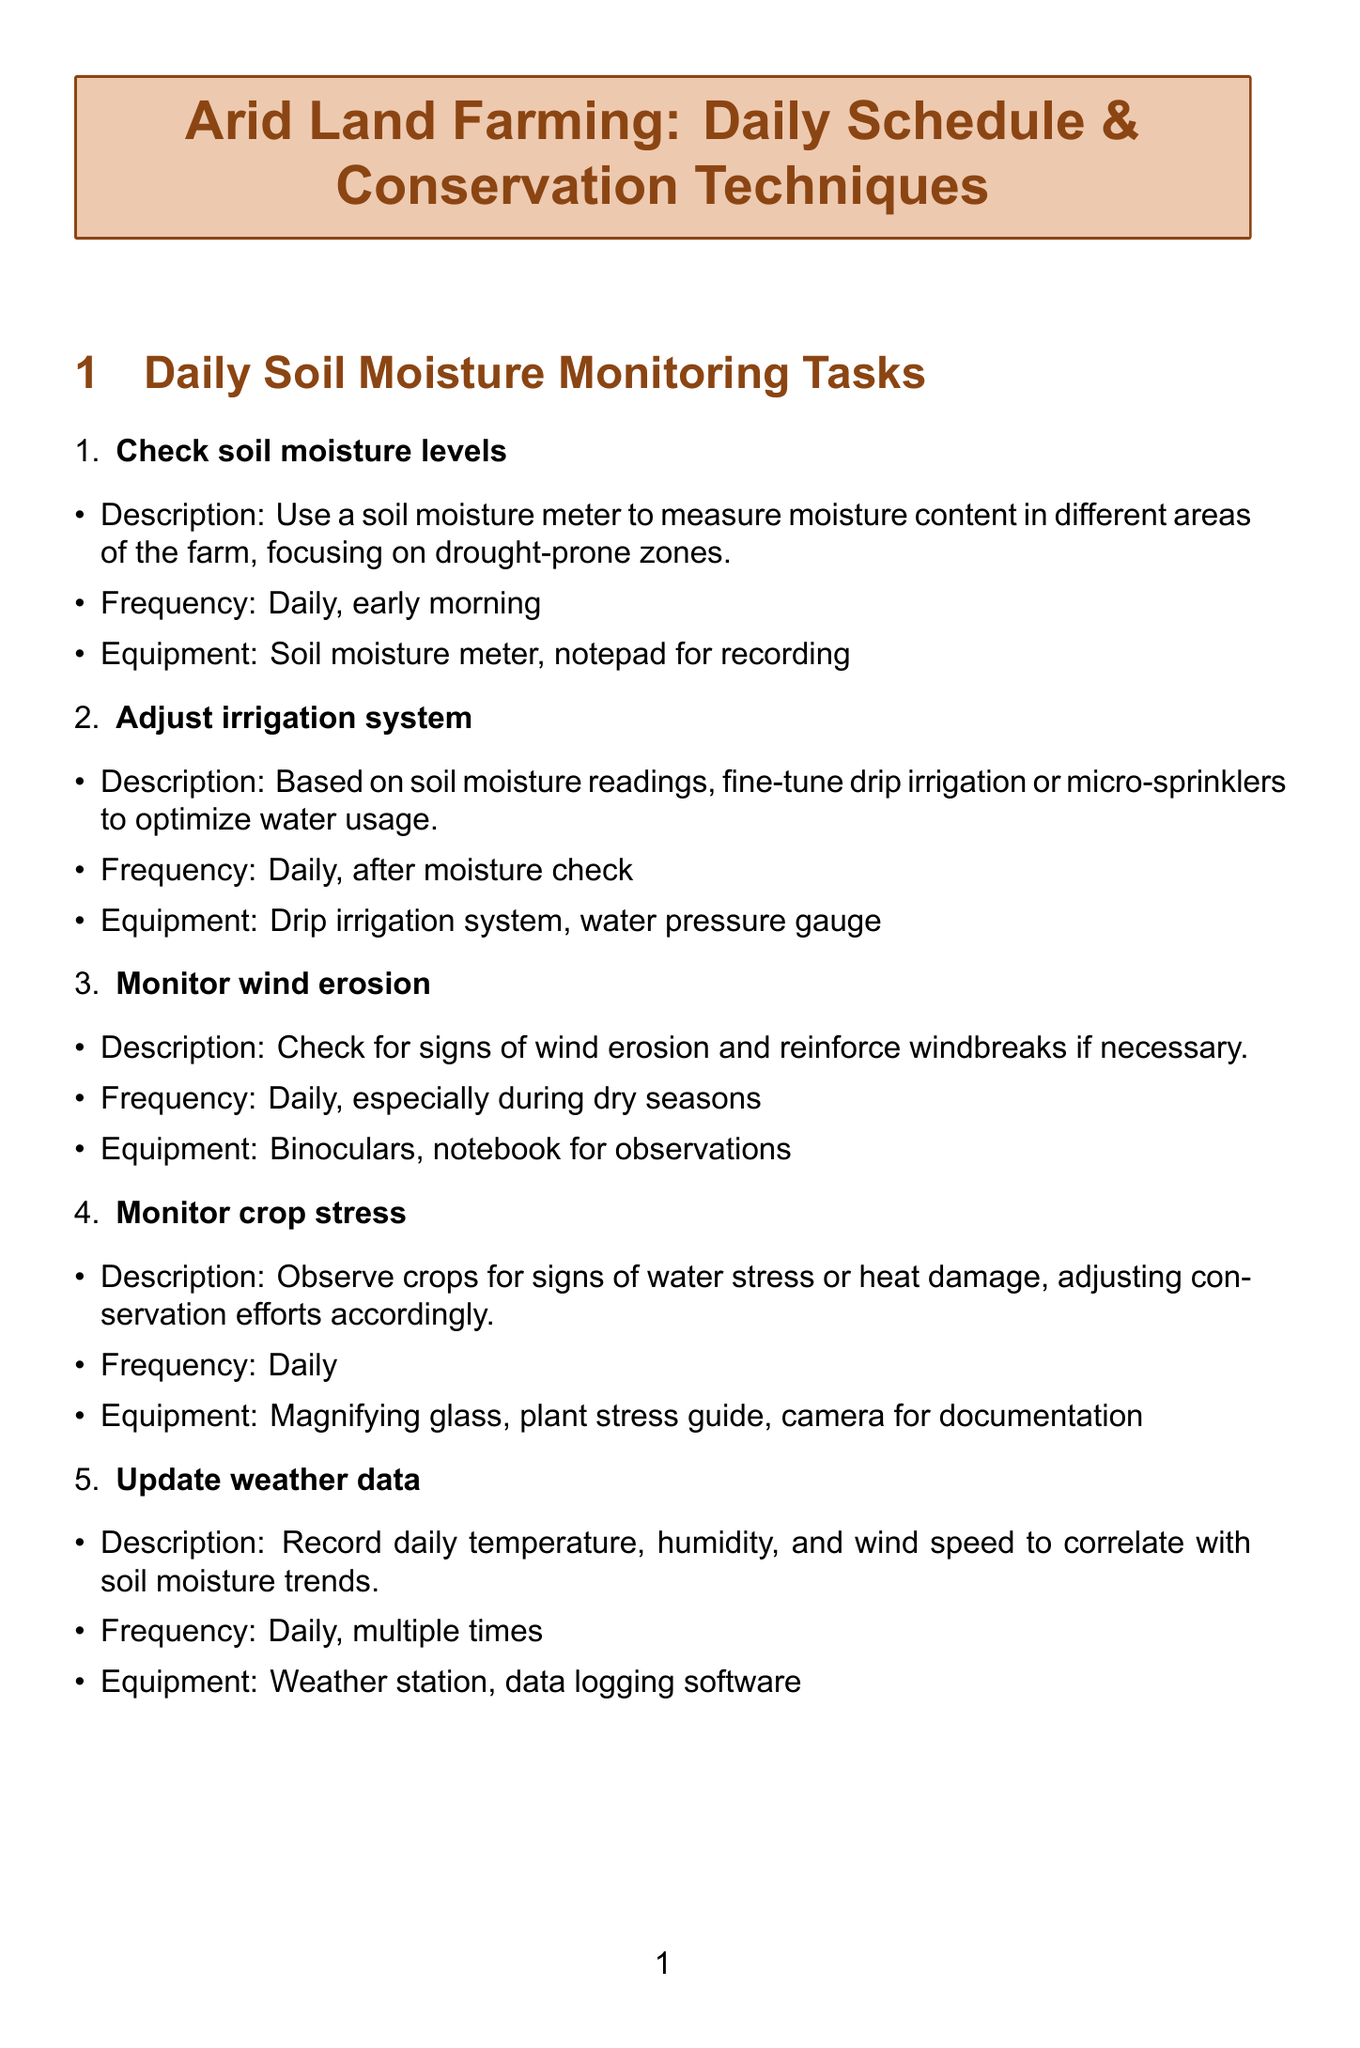what is the first daily task? The first daily task listed is to check soil moisture levels.
Answer: Check soil moisture levels how often should the irrigation system be adjusted? The irrigation system should be adjusted daily after the moisture check.
Answer: Daily, after moisture check what equipment is needed to apply mulch? The equipment needed to apply mulch includes a wheelbarrow, rake, and organic mulch.
Answer: Wheelbarrow, rake, organic mulch how frequently is soil salinity checked? Soil salinity is checked weekly.
Answer: Weekly what technique helps to reduce runoff and erosion? The technique that helps to reduce runoff and erosion is contour plowing.
Answer: Contour plowing how many tasks are listed under daily soil moisture monitoring? There are five tasks listed under daily soil moisture monitoring.
Answer: Five tasks what is one reason for monitoring crop stress? Monitoring crop stress helps to observe crops for signs of water stress or heat damage.
Answer: Water stress or heat damage how are drought-resistant varieties implemented? Drought-resistant varieties are planted during the planting season.
Answer: During planting season what is the purpose of monitoring wind erosion? The purpose is to check for signs of wind erosion and reinforce windbreaks if necessary.
Answer: To check for signs of wind erosion 